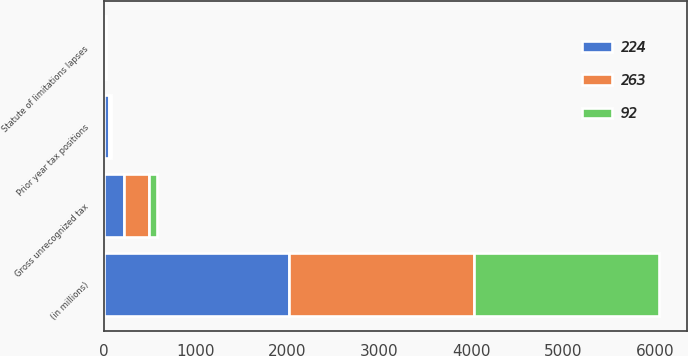<chart> <loc_0><loc_0><loc_500><loc_500><stacked_bar_chart><ecel><fcel>(in millions)<fcel>Gross unrecognized tax<fcel>Prior year tax positions<fcel>Statute of limitations lapses<nl><fcel>263<fcel>2016<fcel>263<fcel>24<fcel>12<nl><fcel>224<fcel>2015<fcel>224<fcel>55<fcel>9<nl><fcel>92<fcel>2014<fcel>92<fcel>4<fcel>1<nl></chart> 